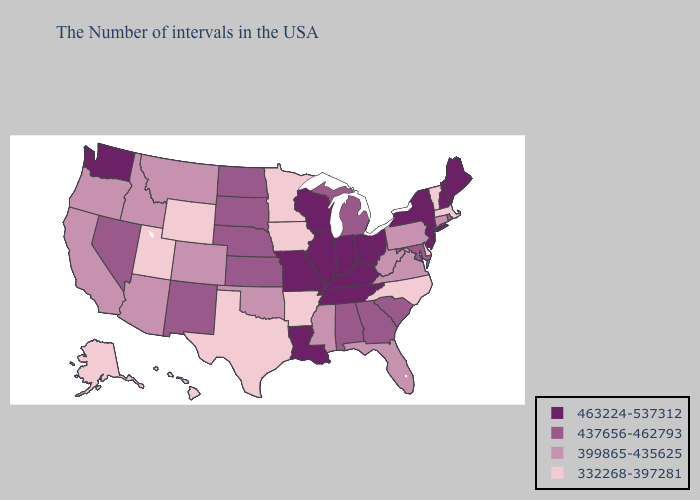Among the states that border Missouri , which have the lowest value?
Be succinct. Arkansas, Iowa. Which states have the lowest value in the South?
Give a very brief answer. Delaware, North Carolina, Arkansas, Texas. Name the states that have a value in the range 463224-537312?
Keep it brief. Maine, New Hampshire, New York, New Jersey, Ohio, Kentucky, Indiana, Tennessee, Wisconsin, Illinois, Louisiana, Missouri, Washington. What is the lowest value in states that border Utah?
Write a very short answer. 332268-397281. What is the highest value in states that border Washington?
Be succinct. 399865-435625. What is the value of South Carolina?
Concise answer only. 437656-462793. Does West Virginia have the same value as Idaho?
Answer briefly. Yes. What is the value of Georgia?
Concise answer only. 437656-462793. Name the states that have a value in the range 463224-537312?
Give a very brief answer. Maine, New Hampshire, New York, New Jersey, Ohio, Kentucky, Indiana, Tennessee, Wisconsin, Illinois, Louisiana, Missouri, Washington. Does Maryland have the lowest value in the USA?
Give a very brief answer. No. Does the first symbol in the legend represent the smallest category?
Answer briefly. No. Is the legend a continuous bar?
Give a very brief answer. No. Which states have the lowest value in the USA?
Answer briefly. Massachusetts, Vermont, Delaware, North Carolina, Arkansas, Minnesota, Iowa, Texas, Wyoming, Utah, Alaska, Hawaii. Does Florida have a higher value than Oregon?
Be succinct. No. 